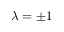<formula> <loc_0><loc_0><loc_500><loc_500>\lambda = \pm 1</formula> 